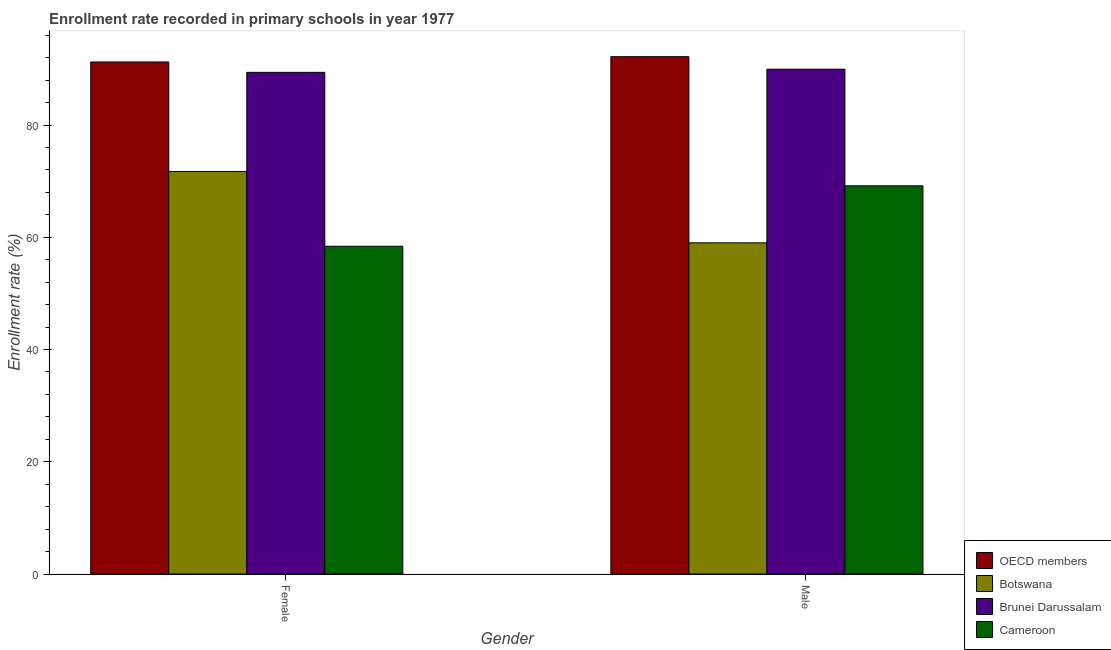How many different coloured bars are there?
Keep it short and to the point. 4. How many groups of bars are there?
Offer a terse response. 2. Are the number of bars on each tick of the X-axis equal?
Make the answer very short. Yes. What is the enrollment rate of female students in Cameroon?
Provide a short and direct response. 58.4. Across all countries, what is the maximum enrollment rate of male students?
Give a very brief answer. 92.18. Across all countries, what is the minimum enrollment rate of female students?
Your response must be concise. 58.4. In which country was the enrollment rate of male students minimum?
Make the answer very short. Botswana. What is the total enrollment rate of female students in the graph?
Offer a terse response. 310.76. What is the difference between the enrollment rate of male students in OECD members and that in Brunei Darussalam?
Keep it short and to the point. 2.23. What is the difference between the enrollment rate of female students in Cameroon and the enrollment rate of male students in OECD members?
Keep it short and to the point. -33.78. What is the average enrollment rate of female students per country?
Give a very brief answer. 77.69. What is the difference between the enrollment rate of male students and enrollment rate of female students in OECD members?
Offer a terse response. 0.94. In how many countries, is the enrollment rate of male students greater than 24 %?
Your answer should be very brief. 4. What is the ratio of the enrollment rate of male students in OECD members to that in Brunei Darussalam?
Provide a succinct answer. 1.02. What does the 2nd bar from the left in Female represents?
Keep it short and to the point. Botswana. What does the 3rd bar from the right in Female represents?
Ensure brevity in your answer.  Botswana. How many bars are there?
Your answer should be very brief. 8. Are all the bars in the graph horizontal?
Your response must be concise. No. How many countries are there in the graph?
Offer a very short reply. 4. What is the difference between two consecutive major ticks on the Y-axis?
Give a very brief answer. 20. Are the values on the major ticks of Y-axis written in scientific E-notation?
Keep it short and to the point. No. Does the graph contain any zero values?
Make the answer very short. No. Does the graph contain grids?
Provide a short and direct response. No. How many legend labels are there?
Ensure brevity in your answer.  4. What is the title of the graph?
Make the answer very short. Enrollment rate recorded in primary schools in year 1977. What is the label or title of the Y-axis?
Your answer should be compact. Enrollment rate (%). What is the Enrollment rate (%) in OECD members in Female?
Offer a terse response. 91.24. What is the Enrollment rate (%) of Botswana in Female?
Provide a succinct answer. 71.73. What is the Enrollment rate (%) in Brunei Darussalam in Female?
Your answer should be very brief. 89.39. What is the Enrollment rate (%) in Cameroon in Female?
Ensure brevity in your answer.  58.4. What is the Enrollment rate (%) of OECD members in Male?
Offer a very short reply. 92.18. What is the Enrollment rate (%) in Botswana in Male?
Your answer should be very brief. 59.02. What is the Enrollment rate (%) of Brunei Darussalam in Male?
Your answer should be very brief. 89.95. What is the Enrollment rate (%) of Cameroon in Male?
Your answer should be compact. 69.17. Across all Gender, what is the maximum Enrollment rate (%) of OECD members?
Provide a short and direct response. 92.18. Across all Gender, what is the maximum Enrollment rate (%) of Botswana?
Give a very brief answer. 71.73. Across all Gender, what is the maximum Enrollment rate (%) in Brunei Darussalam?
Provide a succinct answer. 89.95. Across all Gender, what is the maximum Enrollment rate (%) in Cameroon?
Offer a terse response. 69.17. Across all Gender, what is the minimum Enrollment rate (%) of OECD members?
Offer a very short reply. 91.24. Across all Gender, what is the minimum Enrollment rate (%) in Botswana?
Your response must be concise. 59.02. Across all Gender, what is the minimum Enrollment rate (%) of Brunei Darussalam?
Ensure brevity in your answer.  89.39. Across all Gender, what is the minimum Enrollment rate (%) of Cameroon?
Give a very brief answer. 58.4. What is the total Enrollment rate (%) of OECD members in the graph?
Your response must be concise. 183.42. What is the total Enrollment rate (%) in Botswana in the graph?
Provide a short and direct response. 130.74. What is the total Enrollment rate (%) of Brunei Darussalam in the graph?
Your answer should be compact. 179.34. What is the total Enrollment rate (%) of Cameroon in the graph?
Make the answer very short. 127.57. What is the difference between the Enrollment rate (%) of OECD members in Female and that in Male?
Ensure brevity in your answer.  -0.94. What is the difference between the Enrollment rate (%) of Botswana in Female and that in Male?
Offer a very short reply. 12.71. What is the difference between the Enrollment rate (%) of Brunei Darussalam in Female and that in Male?
Offer a terse response. -0.56. What is the difference between the Enrollment rate (%) in Cameroon in Female and that in Male?
Provide a succinct answer. -10.77. What is the difference between the Enrollment rate (%) in OECD members in Female and the Enrollment rate (%) in Botswana in Male?
Your answer should be very brief. 32.22. What is the difference between the Enrollment rate (%) in OECD members in Female and the Enrollment rate (%) in Brunei Darussalam in Male?
Offer a very short reply. 1.28. What is the difference between the Enrollment rate (%) in OECD members in Female and the Enrollment rate (%) in Cameroon in Male?
Provide a short and direct response. 22.07. What is the difference between the Enrollment rate (%) of Botswana in Female and the Enrollment rate (%) of Brunei Darussalam in Male?
Offer a terse response. -18.23. What is the difference between the Enrollment rate (%) in Botswana in Female and the Enrollment rate (%) in Cameroon in Male?
Keep it short and to the point. 2.56. What is the difference between the Enrollment rate (%) of Brunei Darussalam in Female and the Enrollment rate (%) of Cameroon in Male?
Keep it short and to the point. 20.22. What is the average Enrollment rate (%) in OECD members per Gender?
Your response must be concise. 91.71. What is the average Enrollment rate (%) in Botswana per Gender?
Your answer should be very brief. 65.37. What is the average Enrollment rate (%) in Brunei Darussalam per Gender?
Your answer should be compact. 89.67. What is the average Enrollment rate (%) in Cameroon per Gender?
Make the answer very short. 63.79. What is the difference between the Enrollment rate (%) in OECD members and Enrollment rate (%) in Botswana in Female?
Give a very brief answer. 19.51. What is the difference between the Enrollment rate (%) in OECD members and Enrollment rate (%) in Brunei Darussalam in Female?
Offer a terse response. 1.85. What is the difference between the Enrollment rate (%) of OECD members and Enrollment rate (%) of Cameroon in Female?
Your answer should be compact. 32.83. What is the difference between the Enrollment rate (%) in Botswana and Enrollment rate (%) in Brunei Darussalam in Female?
Provide a short and direct response. -17.66. What is the difference between the Enrollment rate (%) of Botswana and Enrollment rate (%) of Cameroon in Female?
Offer a terse response. 13.32. What is the difference between the Enrollment rate (%) in Brunei Darussalam and Enrollment rate (%) in Cameroon in Female?
Offer a very short reply. 30.99. What is the difference between the Enrollment rate (%) in OECD members and Enrollment rate (%) in Botswana in Male?
Give a very brief answer. 33.17. What is the difference between the Enrollment rate (%) in OECD members and Enrollment rate (%) in Brunei Darussalam in Male?
Give a very brief answer. 2.23. What is the difference between the Enrollment rate (%) of OECD members and Enrollment rate (%) of Cameroon in Male?
Provide a short and direct response. 23.01. What is the difference between the Enrollment rate (%) of Botswana and Enrollment rate (%) of Brunei Darussalam in Male?
Offer a terse response. -30.94. What is the difference between the Enrollment rate (%) of Botswana and Enrollment rate (%) of Cameroon in Male?
Provide a short and direct response. -10.15. What is the difference between the Enrollment rate (%) of Brunei Darussalam and Enrollment rate (%) of Cameroon in Male?
Provide a short and direct response. 20.78. What is the ratio of the Enrollment rate (%) of Botswana in Female to that in Male?
Offer a terse response. 1.22. What is the ratio of the Enrollment rate (%) in Brunei Darussalam in Female to that in Male?
Provide a short and direct response. 0.99. What is the ratio of the Enrollment rate (%) in Cameroon in Female to that in Male?
Provide a succinct answer. 0.84. What is the difference between the highest and the second highest Enrollment rate (%) in OECD members?
Your answer should be compact. 0.94. What is the difference between the highest and the second highest Enrollment rate (%) in Botswana?
Your answer should be very brief. 12.71. What is the difference between the highest and the second highest Enrollment rate (%) of Brunei Darussalam?
Offer a very short reply. 0.56. What is the difference between the highest and the second highest Enrollment rate (%) of Cameroon?
Provide a succinct answer. 10.77. What is the difference between the highest and the lowest Enrollment rate (%) in OECD members?
Your response must be concise. 0.94. What is the difference between the highest and the lowest Enrollment rate (%) in Botswana?
Ensure brevity in your answer.  12.71. What is the difference between the highest and the lowest Enrollment rate (%) in Brunei Darussalam?
Make the answer very short. 0.56. What is the difference between the highest and the lowest Enrollment rate (%) of Cameroon?
Make the answer very short. 10.77. 